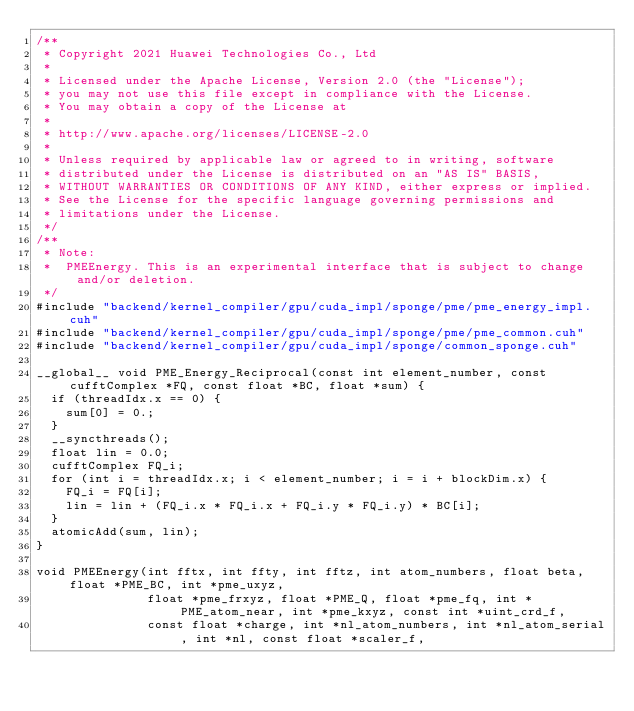Convert code to text. <code><loc_0><loc_0><loc_500><loc_500><_Cuda_>/**
 * Copyright 2021 Huawei Technologies Co., Ltd
 *
 * Licensed under the Apache License, Version 2.0 (the "License");
 * you may not use this file except in compliance with the License.
 * You may obtain a copy of the License at
 *
 * http://www.apache.org/licenses/LICENSE-2.0
 *
 * Unless required by applicable law or agreed to in writing, software
 * distributed under the License is distributed on an "AS IS" BASIS,
 * WITHOUT WARRANTIES OR CONDITIONS OF ANY KIND, either express or implied.
 * See the License for the specific language governing permissions and
 * limitations under the License.
 */
/**
 * Note:
 *  PMEEnergy. This is an experimental interface that is subject to change and/or deletion.
 */
#include "backend/kernel_compiler/gpu/cuda_impl/sponge/pme/pme_energy_impl.cuh"
#include "backend/kernel_compiler/gpu/cuda_impl/sponge/pme/pme_common.cuh"
#include "backend/kernel_compiler/gpu/cuda_impl/sponge/common_sponge.cuh"

__global__ void PME_Energy_Reciprocal(const int element_number, const cufftComplex *FQ, const float *BC, float *sum) {
  if (threadIdx.x == 0) {
    sum[0] = 0.;
  }
  __syncthreads();
  float lin = 0.0;
  cufftComplex FQ_i;
  for (int i = threadIdx.x; i < element_number; i = i + blockDim.x) {
    FQ_i = FQ[i];
    lin = lin + (FQ_i.x * FQ_i.x + FQ_i.y * FQ_i.y) * BC[i];
  }
  atomicAdd(sum, lin);
}

void PMEEnergy(int fftx, int ffty, int fftz, int atom_numbers, float beta, float *PME_BC, int *pme_uxyz,
               float *pme_frxyz, float *PME_Q, float *pme_fq, int *PME_atom_near, int *pme_kxyz, const int *uint_crd_f,
               const float *charge, int *nl_atom_numbers, int *nl_atom_serial, int *nl, const float *scaler_f,</code> 